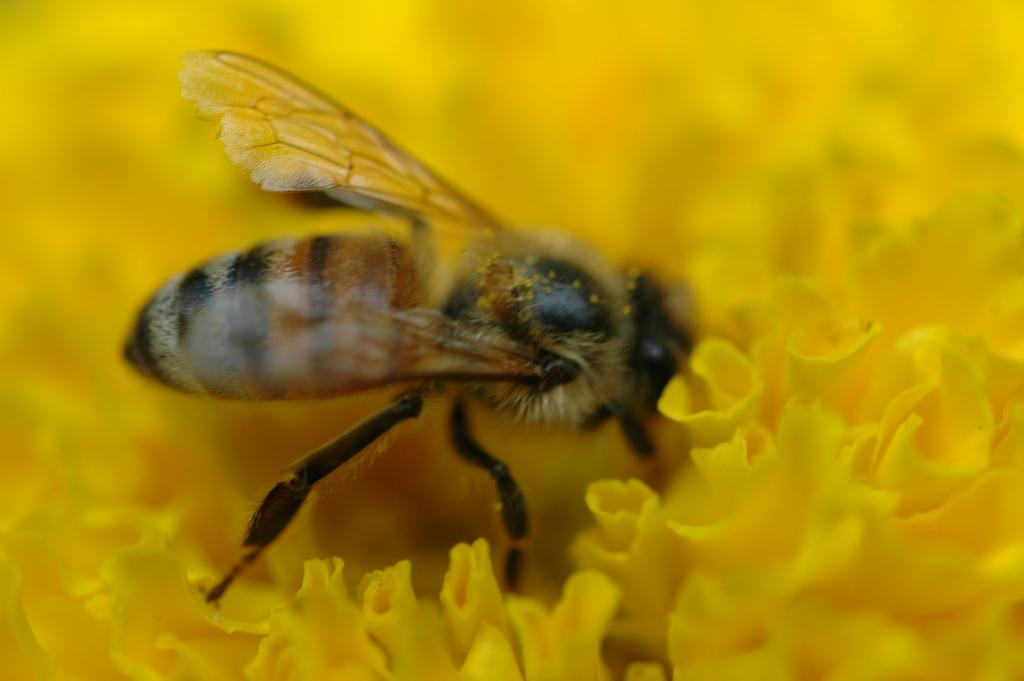What type of insect is in the image? There is a honey bee in the image. Where is the honey bee located in the image? The honey bee is on the flowers. What type of hose is being used by the babies in the image? There are no babies or hoses present in the image; it features a honey bee on flowers. 